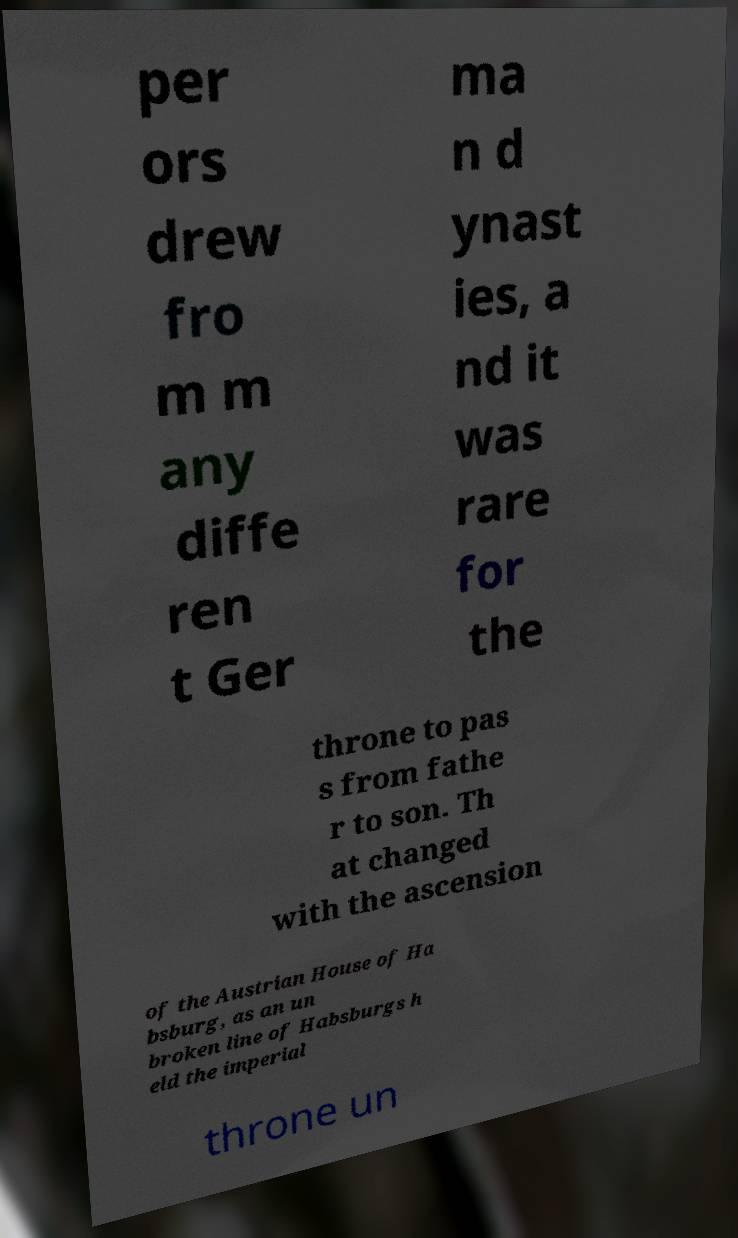What messages or text are displayed in this image? I need them in a readable, typed format. per ors drew fro m m any diffe ren t Ger ma n d ynast ies, a nd it was rare for the throne to pas s from fathe r to son. Th at changed with the ascension of the Austrian House of Ha bsburg, as an un broken line of Habsburgs h eld the imperial throne un 